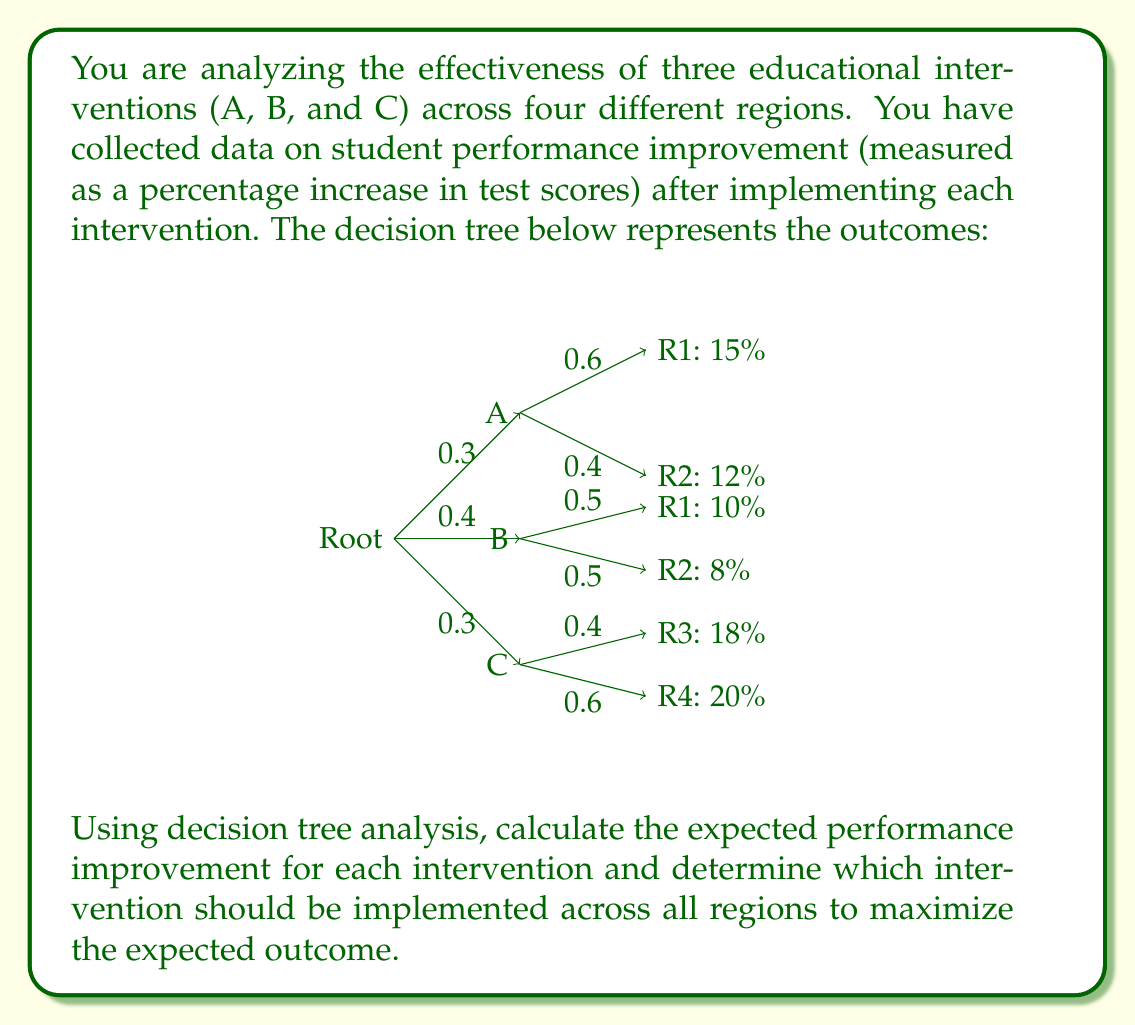Solve this math problem. To solve this problem, we need to calculate the expected value of each intervention using the decision tree analysis. Let's go through it step by step:

1. Calculate the expected value for Intervention A:
   $$E(A) = 0.6 \times 15\% + 0.4 \times 12\% = 9\% + 4.8\% = 13.8\%$$

2. Calculate the expected value for Intervention B:
   $$E(B) = 0.5 \times 10\% + 0.5 \times 8\% = 5\% + 4\% = 9\%$$

3. Calculate the expected value for Intervention C:
   $$E(C) = 0.4 \times 18\% + 0.6 \times 20\% = 7.2\% + 12\% = 19.2\%$$

4. Now, we need to calculate the overall expected value for each intervention, considering the probabilities of choosing each intervention:

   Intervention A: $0.3 \times 13.8\% = 4.14\%$
   Intervention B: $0.4 \times 9\% = 3.6\%$
   Intervention C: $0.3 \times 19.2\% = 5.76\%$

5. The total expected value is the sum of these:
   $$E(\text{total}) = 4.14\% + 3.6\% + 5.76\% = 13.5\%$$

6. To maximize the expected outcome, we should choose the intervention with the highest expected value, which is Intervention C with 19.2%.
Answer: The intervention that should be implemented across all regions to maximize the expected outcome is Intervention C, with an expected performance improvement of 19.2%. 